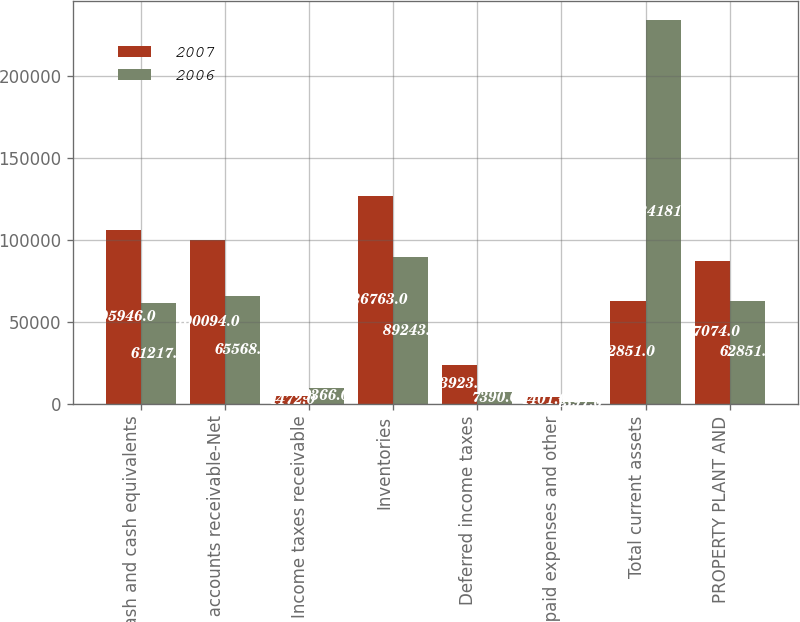<chart> <loc_0><loc_0><loc_500><loc_500><stacked_bar_chart><ecel><fcel>Cash and cash equivalents<fcel>Trade accounts receivable-Net<fcel>Income taxes receivable<fcel>Inventories<fcel>Deferred income taxes<fcel>Prepaid expenses and other<fcel>Total current assets<fcel>PROPERTY PLANT AND<nl><fcel>2007<fcel>105946<fcel>100094<fcel>4472<fcel>126763<fcel>23923<fcel>4401<fcel>62851<fcel>87074<nl><fcel>2006<fcel>61217<fcel>65568<fcel>9366<fcel>89243<fcel>7390<fcel>1397<fcel>234181<fcel>62851<nl></chart> 